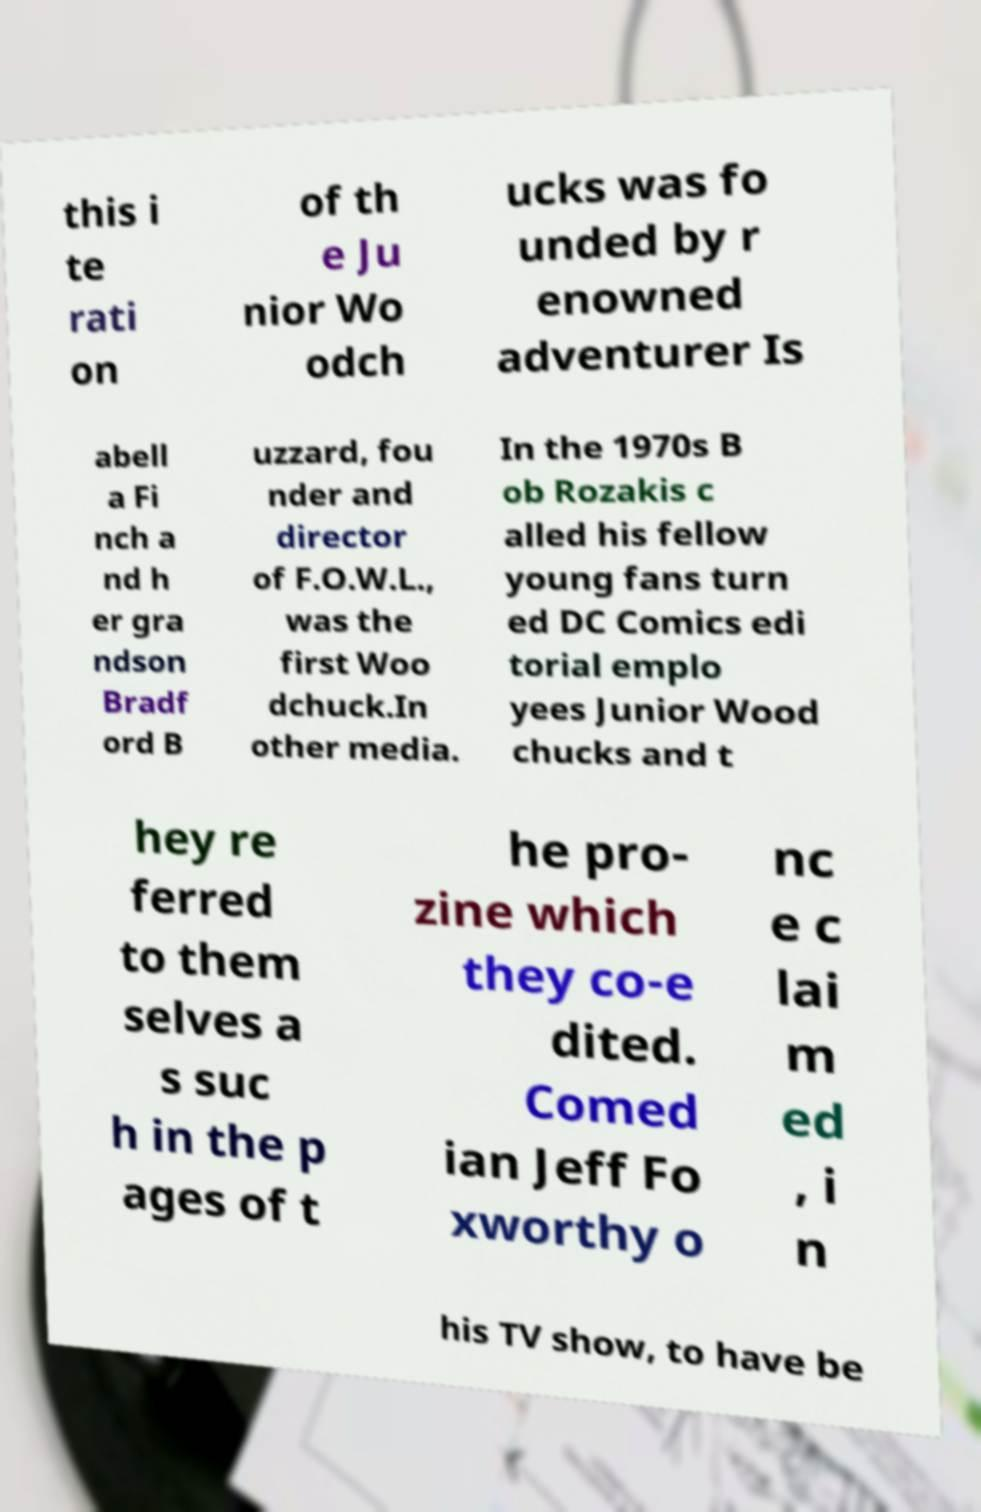For documentation purposes, I need the text within this image transcribed. Could you provide that? this i te rati on of th e Ju nior Wo odch ucks was fo unded by r enowned adventurer Is abell a Fi nch a nd h er gra ndson Bradf ord B uzzard, fou nder and director of F.O.W.L., was the first Woo dchuck.In other media. In the 1970s B ob Rozakis c alled his fellow young fans turn ed DC Comics edi torial emplo yees Junior Wood chucks and t hey re ferred to them selves a s suc h in the p ages of t he pro- zine which they co-e dited. Comed ian Jeff Fo xworthy o nc e c lai m ed , i n his TV show, to have be 